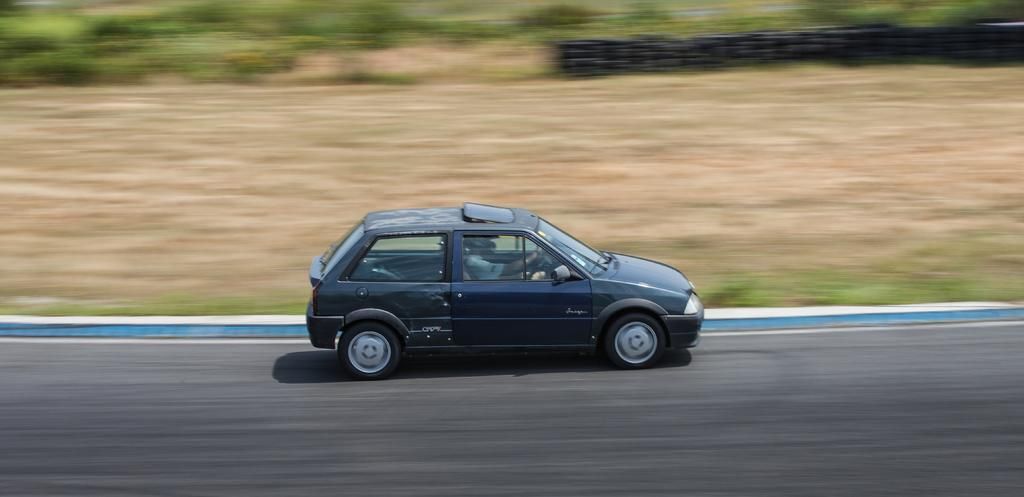What is the main subject of the image? There is a car in the image. Where is the car located? The car is on the road. What can be seen in the background of the image? There are trees in the background of the image. What type of ink is being used to write on the car in the image? There is no ink or writing present on the car in the image. Is there an army base visible in the image? There is no army base or any indication of military presence in the image. 